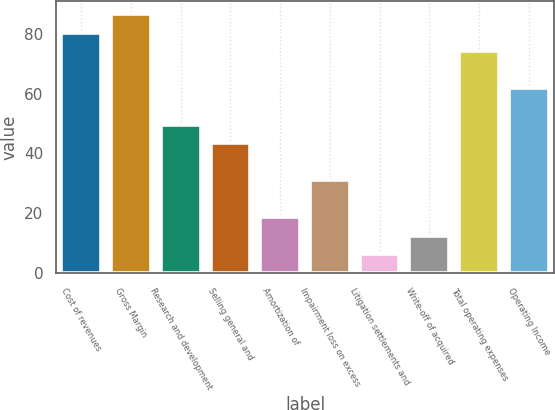Convert chart to OTSL. <chart><loc_0><loc_0><loc_500><loc_500><bar_chart><fcel>Cost of revenues<fcel>Gross Margin<fcel>Research and development<fcel>Selling general and<fcel>Amortization of<fcel>Impairment loss on excess<fcel>Litigation settlements and<fcel>Write-off of acquired<fcel>Total operating expenses<fcel>Operating Income<nl><fcel>80.44<fcel>86.62<fcel>49.54<fcel>43.36<fcel>18.64<fcel>31<fcel>6.28<fcel>12.46<fcel>74.26<fcel>61.9<nl></chart> 